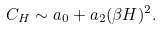<formula> <loc_0><loc_0><loc_500><loc_500>C _ { H } \sim a _ { 0 } + a _ { 2 } ( \beta H ) ^ { 2 } .</formula> 